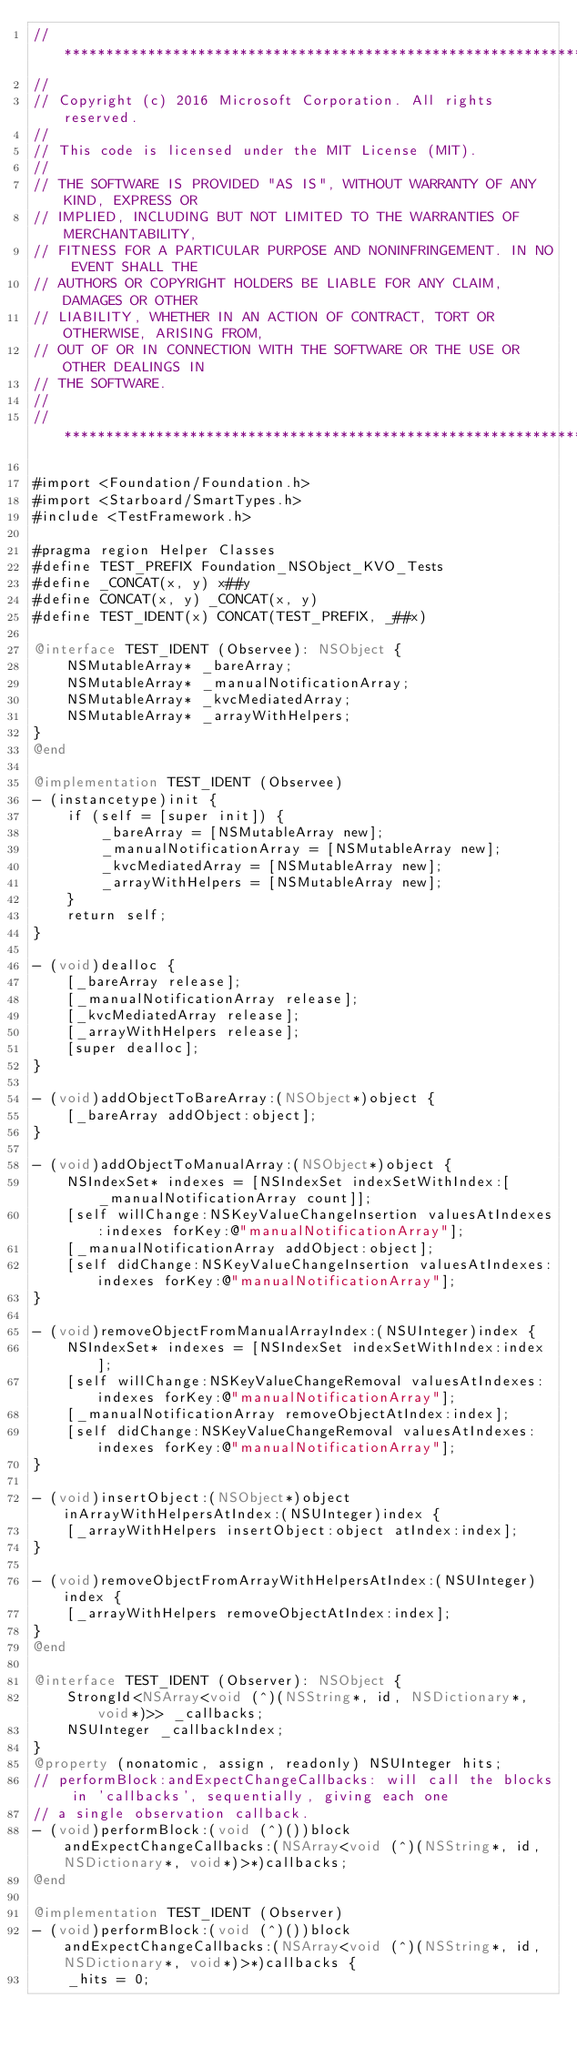<code> <loc_0><loc_0><loc_500><loc_500><_ObjectiveC_>//******************************************************************************
//
// Copyright (c) 2016 Microsoft Corporation. All rights reserved.
//
// This code is licensed under the MIT License (MIT).
//
// THE SOFTWARE IS PROVIDED "AS IS", WITHOUT WARRANTY OF ANY KIND, EXPRESS OR
// IMPLIED, INCLUDING BUT NOT LIMITED TO THE WARRANTIES OF MERCHANTABILITY,
// FITNESS FOR A PARTICULAR PURPOSE AND NONINFRINGEMENT. IN NO EVENT SHALL THE
// AUTHORS OR COPYRIGHT HOLDERS BE LIABLE FOR ANY CLAIM, DAMAGES OR OTHER
// LIABILITY, WHETHER IN AN ACTION OF CONTRACT, TORT OR OTHERWISE, ARISING FROM,
// OUT OF OR IN CONNECTION WITH THE SOFTWARE OR THE USE OR OTHER DEALINGS IN
// THE SOFTWARE.
//
//******************************************************************************

#import <Foundation/Foundation.h>
#import <Starboard/SmartTypes.h>
#include <TestFramework.h>

#pragma region Helper Classes
#define TEST_PREFIX Foundation_NSObject_KVO_Tests
#define _CONCAT(x, y) x##y
#define CONCAT(x, y) _CONCAT(x, y)
#define TEST_IDENT(x) CONCAT(TEST_PREFIX, _##x)

@interface TEST_IDENT (Observee): NSObject {
    NSMutableArray* _bareArray;
    NSMutableArray* _manualNotificationArray;
    NSMutableArray* _kvcMediatedArray;
    NSMutableArray* _arrayWithHelpers;
}
@end

@implementation TEST_IDENT (Observee)
- (instancetype)init {
    if (self = [super init]) {
        _bareArray = [NSMutableArray new];
        _manualNotificationArray = [NSMutableArray new];
        _kvcMediatedArray = [NSMutableArray new];
        _arrayWithHelpers = [NSMutableArray new];
    }
    return self;
}

- (void)dealloc {
    [_bareArray release];
    [_manualNotificationArray release];
    [_kvcMediatedArray release];
    [_arrayWithHelpers release];
    [super dealloc];
}

- (void)addObjectToBareArray:(NSObject*)object {
    [_bareArray addObject:object];
}

- (void)addObjectToManualArray:(NSObject*)object {
    NSIndexSet* indexes = [NSIndexSet indexSetWithIndex:[_manualNotificationArray count]];
    [self willChange:NSKeyValueChangeInsertion valuesAtIndexes:indexes forKey:@"manualNotificationArray"];
    [_manualNotificationArray addObject:object];
    [self didChange:NSKeyValueChangeInsertion valuesAtIndexes:indexes forKey:@"manualNotificationArray"];
}

- (void)removeObjectFromManualArrayIndex:(NSUInteger)index {
    NSIndexSet* indexes = [NSIndexSet indexSetWithIndex:index];
    [self willChange:NSKeyValueChangeRemoval valuesAtIndexes:indexes forKey:@"manualNotificationArray"];
    [_manualNotificationArray removeObjectAtIndex:index];
    [self didChange:NSKeyValueChangeRemoval valuesAtIndexes:indexes forKey:@"manualNotificationArray"];
}

- (void)insertObject:(NSObject*)object inArrayWithHelpersAtIndex:(NSUInteger)index {
    [_arrayWithHelpers insertObject:object atIndex:index];
}

- (void)removeObjectFromArrayWithHelpersAtIndex:(NSUInteger)index {
    [_arrayWithHelpers removeObjectAtIndex:index];
}
@end

@interface TEST_IDENT (Observer): NSObject {
    StrongId<NSArray<void (^)(NSString*, id, NSDictionary*, void*)>> _callbacks;
    NSUInteger _callbackIndex;
}
@property (nonatomic, assign, readonly) NSUInteger hits;
// performBlock:andExpectChangeCallbacks: will call the blocks in 'callbacks', sequentially, giving each one
// a single observation callback.
- (void)performBlock:(void (^)())block andExpectChangeCallbacks:(NSArray<void (^)(NSString*, id, NSDictionary*, void*)>*)callbacks;
@end

@implementation TEST_IDENT (Observer)
- (void)performBlock:(void (^)())block andExpectChangeCallbacks:(NSArray<void (^)(NSString*, id, NSDictionary*, void*)>*)callbacks {
    _hits = 0;</code> 